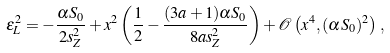<formula> <loc_0><loc_0><loc_500><loc_500>\epsilon _ { L } ^ { 2 } = - \frac { \alpha S _ { 0 } } { 2 s _ { Z } ^ { 2 } } + x ^ { 2 } \left ( \frac { 1 } { 2 } - \frac { ( 3 a + 1 ) \alpha S _ { 0 } } { 8 a s _ { Z } ^ { 2 } } \right ) + \mathcal { O } \left ( x ^ { 4 } , ( \alpha S _ { 0 } ) ^ { 2 } \right ) \, ,</formula> 